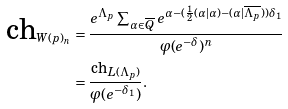<formula> <loc_0><loc_0><loc_500><loc_500>\text {ch} _ { W ( p ) _ { n } } & = \frac { e ^ { \Lambda _ { p } } \sum _ { \alpha \in \overline { Q } } e ^ { \alpha - ( \frac { 1 } { 2 } ( \alpha | \alpha ) - ( \alpha | \overline { \Lambda _ { p } } ) ) \delta _ { 1 } } } { \varphi ( e ^ { - \delta } ) ^ { n } } \\ & = \frac { \text {ch} _ { L ( \Lambda _ { p } ) } } { \varphi ( e ^ { - \delta _ { 1 } } ) } .</formula> 